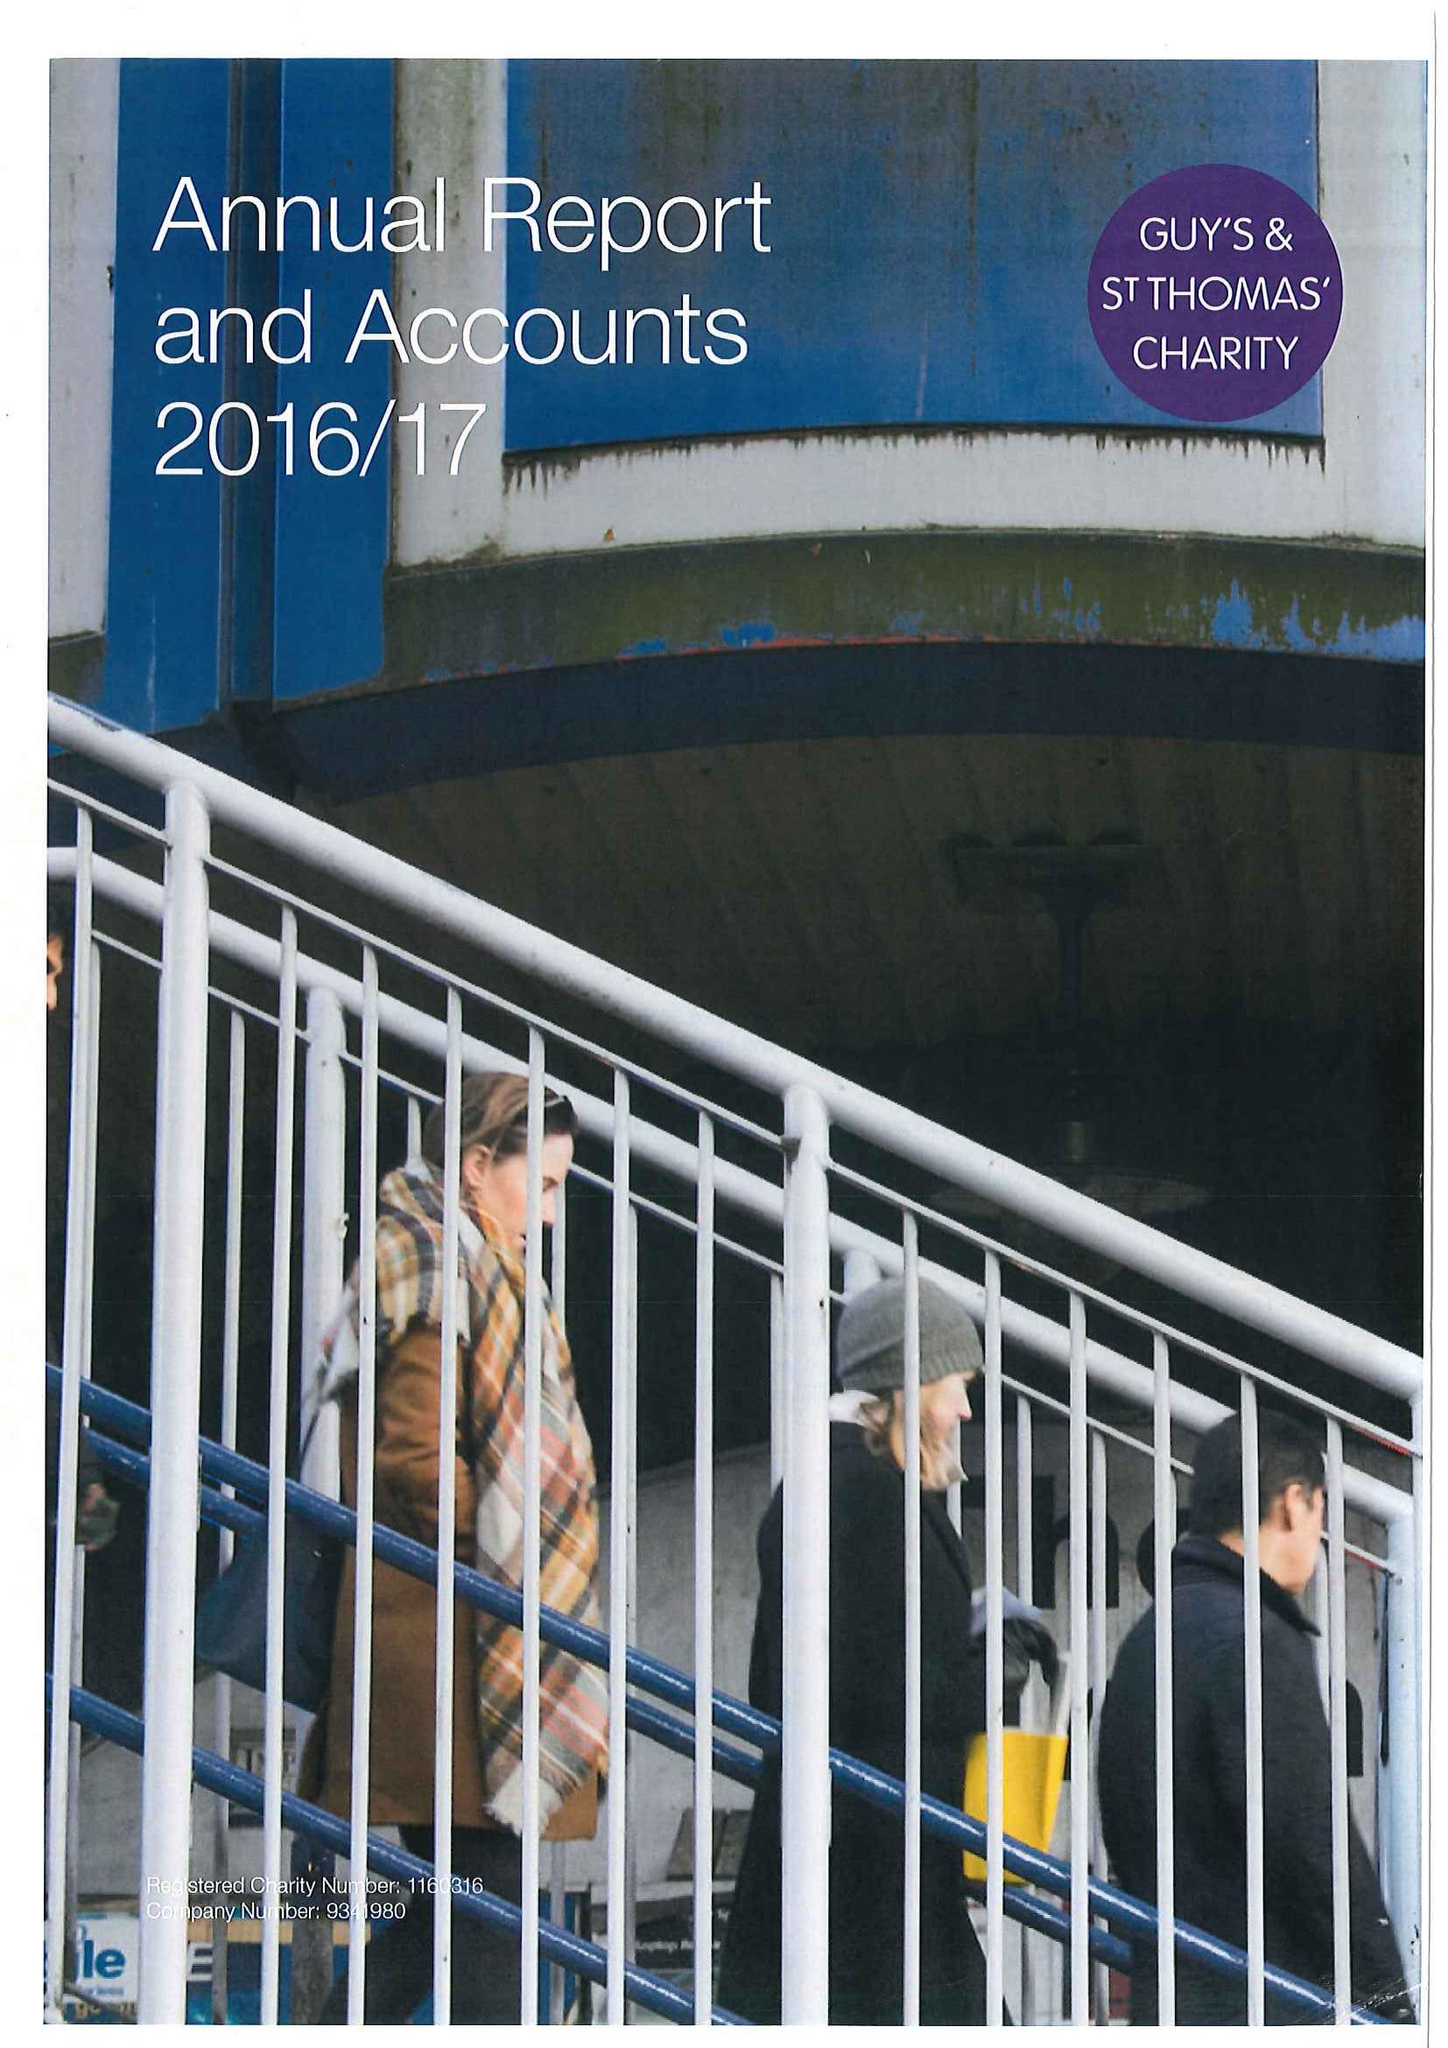What is the value for the income_annually_in_british_pounds?
Answer the question using a single word or phrase. 27103000.00 